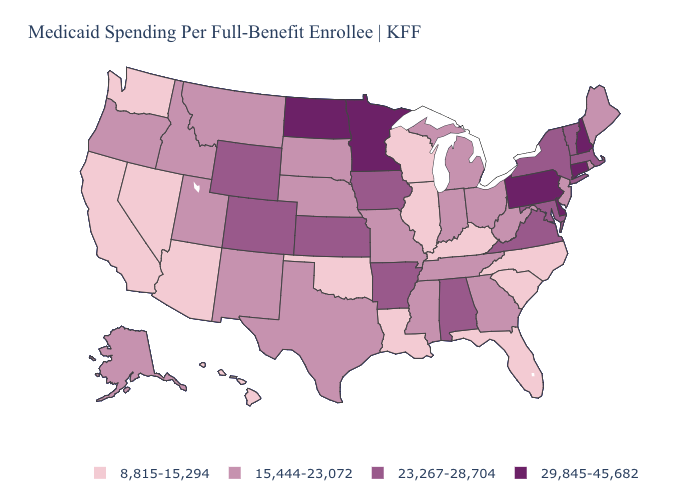Does Kentucky have a lower value than Minnesota?
Short answer required. Yes. Does New Hampshire have the highest value in the USA?
Quick response, please. Yes. Name the states that have a value in the range 15,444-23,072?
Quick response, please. Alaska, Georgia, Idaho, Indiana, Maine, Michigan, Mississippi, Missouri, Montana, Nebraska, New Jersey, New Mexico, Ohio, Oregon, Rhode Island, South Dakota, Tennessee, Texas, Utah, West Virginia. What is the lowest value in the Northeast?
Quick response, please. 15,444-23,072. What is the value of Wisconsin?
Short answer required. 8,815-15,294. What is the highest value in the USA?
Concise answer only. 29,845-45,682. Name the states that have a value in the range 8,815-15,294?
Give a very brief answer. Arizona, California, Florida, Hawaii, Illinois, Kentucky, Louisiana, Nevada, North Carolina, Oklahoma, South Carolina, Washington, Wisconsin. Which states hav the highest value in the MidWest?
Quick response, please. Minnesota, North Dakota. Among the states that border Massachusetts , which have the lowest value?
Short answer required. Rhode Island. Name the states that have a value in the range 8,815-15,294?
Give a very brief answer. Arizona, California, Florida, Hawaii, Illinois, Kentucky, Louisiana, Nevada, North Carolina, Oklahoma, South Carolina, Washington, Wisconsin. What is the lowest value in the West?
Be succinct. 8,815-15,294. Name the states that have a value in the range 15,444-23,072?
Keep it brief. Alaska, Georgia, Idaho, Indiana, Maine, Michigan, Mississippi, Missouri, Montana, Nebraska, New Jersey, New Mexico, Ohio, Oregon, Rhode Island, South Dakota, Tennessee, Texas, Utah, West Virginia. Among the states that border Arkansas , does Tennessee have the lowest value?
Be succinct. No. Which states have the lowest value in the USA?
Be succinct. Arizona, California, Florida, Hawaii, Illinois, Kentucky, Louisiana, Nevada, North Carolina, Oklahoma, South Carolina, Washington, Wisconsin. What is the lowest value in states that border Vermont?
Be succinct. 23,267-28,704. 